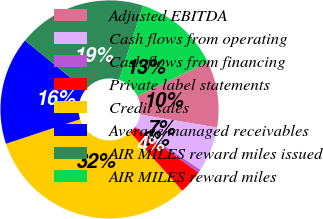<chart> <loc_0><loc_0><loc_500><loc_500><pie_chart><fcel>Adjusted EBITDA<fcel>Cash flows from operating<fcel>Cash flows from financing<fcel>Private label statements<fcel>Credit sales<fcel>Average managed receivables<fcel>AIR MILES reward miles issued<fcel>AIR MILES reward miles<nl><fcel>9.78%<fcel>6.68%<fcel>0.48%<fcel>3.58%<fcel>31.51%<fcel>15.99%<fcel>19.09%<fcel>12.89%<nl></chart> 